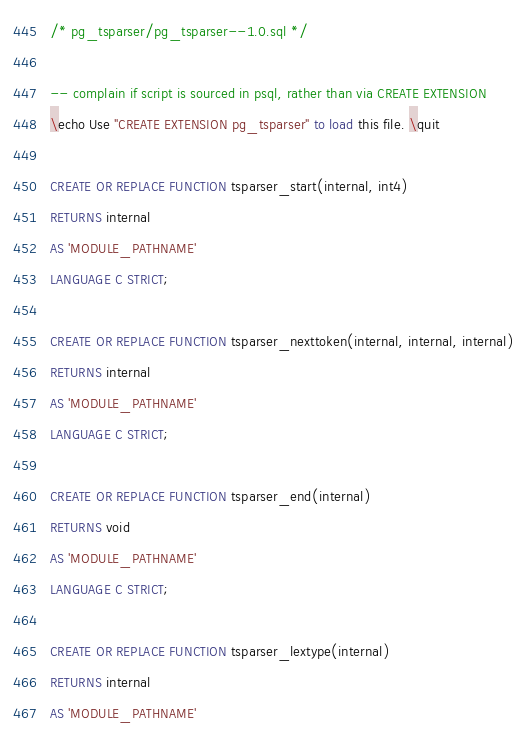Convert code to text. <code><loc_0><loc_0><loc_500><loc_500><_SQL_>/* pg_tsparser/pg_tsparser--1.0.sql */

-- complain if script is sourced in psql, rather than via CREATE EXTENSION
\echo Use "CREATE EXTENSION pg_tsparser" to load this file. \quit

CREATE OR REPLACE FUNCTION tsparser_start(internal, int4)
RETURNS internal
AS 'MODULE_PATHNAME'
LANGUAGE C STRICT;

CREATE OR REPLACE FUNCTION tsparser_nexttoken(internal, internal, internal)
RETURNS internal
AS 'MODULE_PATHNAME'
LANGUAGE C STRICT;

CREATE OR REPLACE FUNCTION tsparser_end(internal)
RETURNS void
AS 'MODULE_PATHNAME'
LANGUAGE C STRICT;

CREATE OR REPLACE FUNCTION tsparser_lextype(internal)
RETURNS internal
AS 'MODULE_PATHNAME'</code> 